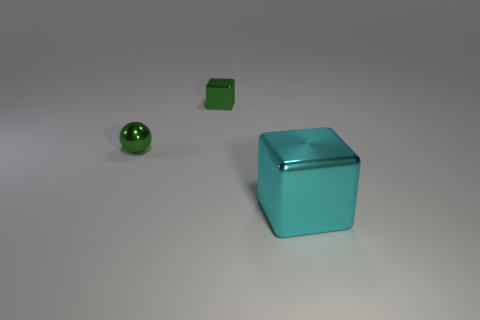How many other objects are the same shape as the big shiny object?
Keep it short and to the point. 1. The tiny shiny object that is behind the small thing in front of the tiny metallic block is what shape?
Give a very brief answer. Cube. There is a green ball; does it have the same size as the cube that is behind the shiny sphere?
Ensure brevity in your answer.  Yes. What material is the object in front of the small shiny sphere?
Make the answer very short. Metal. What number of things are both to the right of the green ball and on the left side of the big cube?
Offer a terse response. 1. There is a shiny block that is behind the large cyan cube; does it have the same size as the thing that is to the left of the tiny green metallic block?
Offer a very short reply. Yes. Are there any tiny green metallic things behind the cyan metallic block?
Give a very brief answer. Yes. What is the color of the metal block that is in front of the block that is on the left side of the large cyan object?
Your response must be concise. Cyan. Are there fewer tiny shiny blocks than gray cylinders?
Your answer should be compact. No. How many other big shiny things have the same shape as the large thing?
Offer a very short reply. 0. 